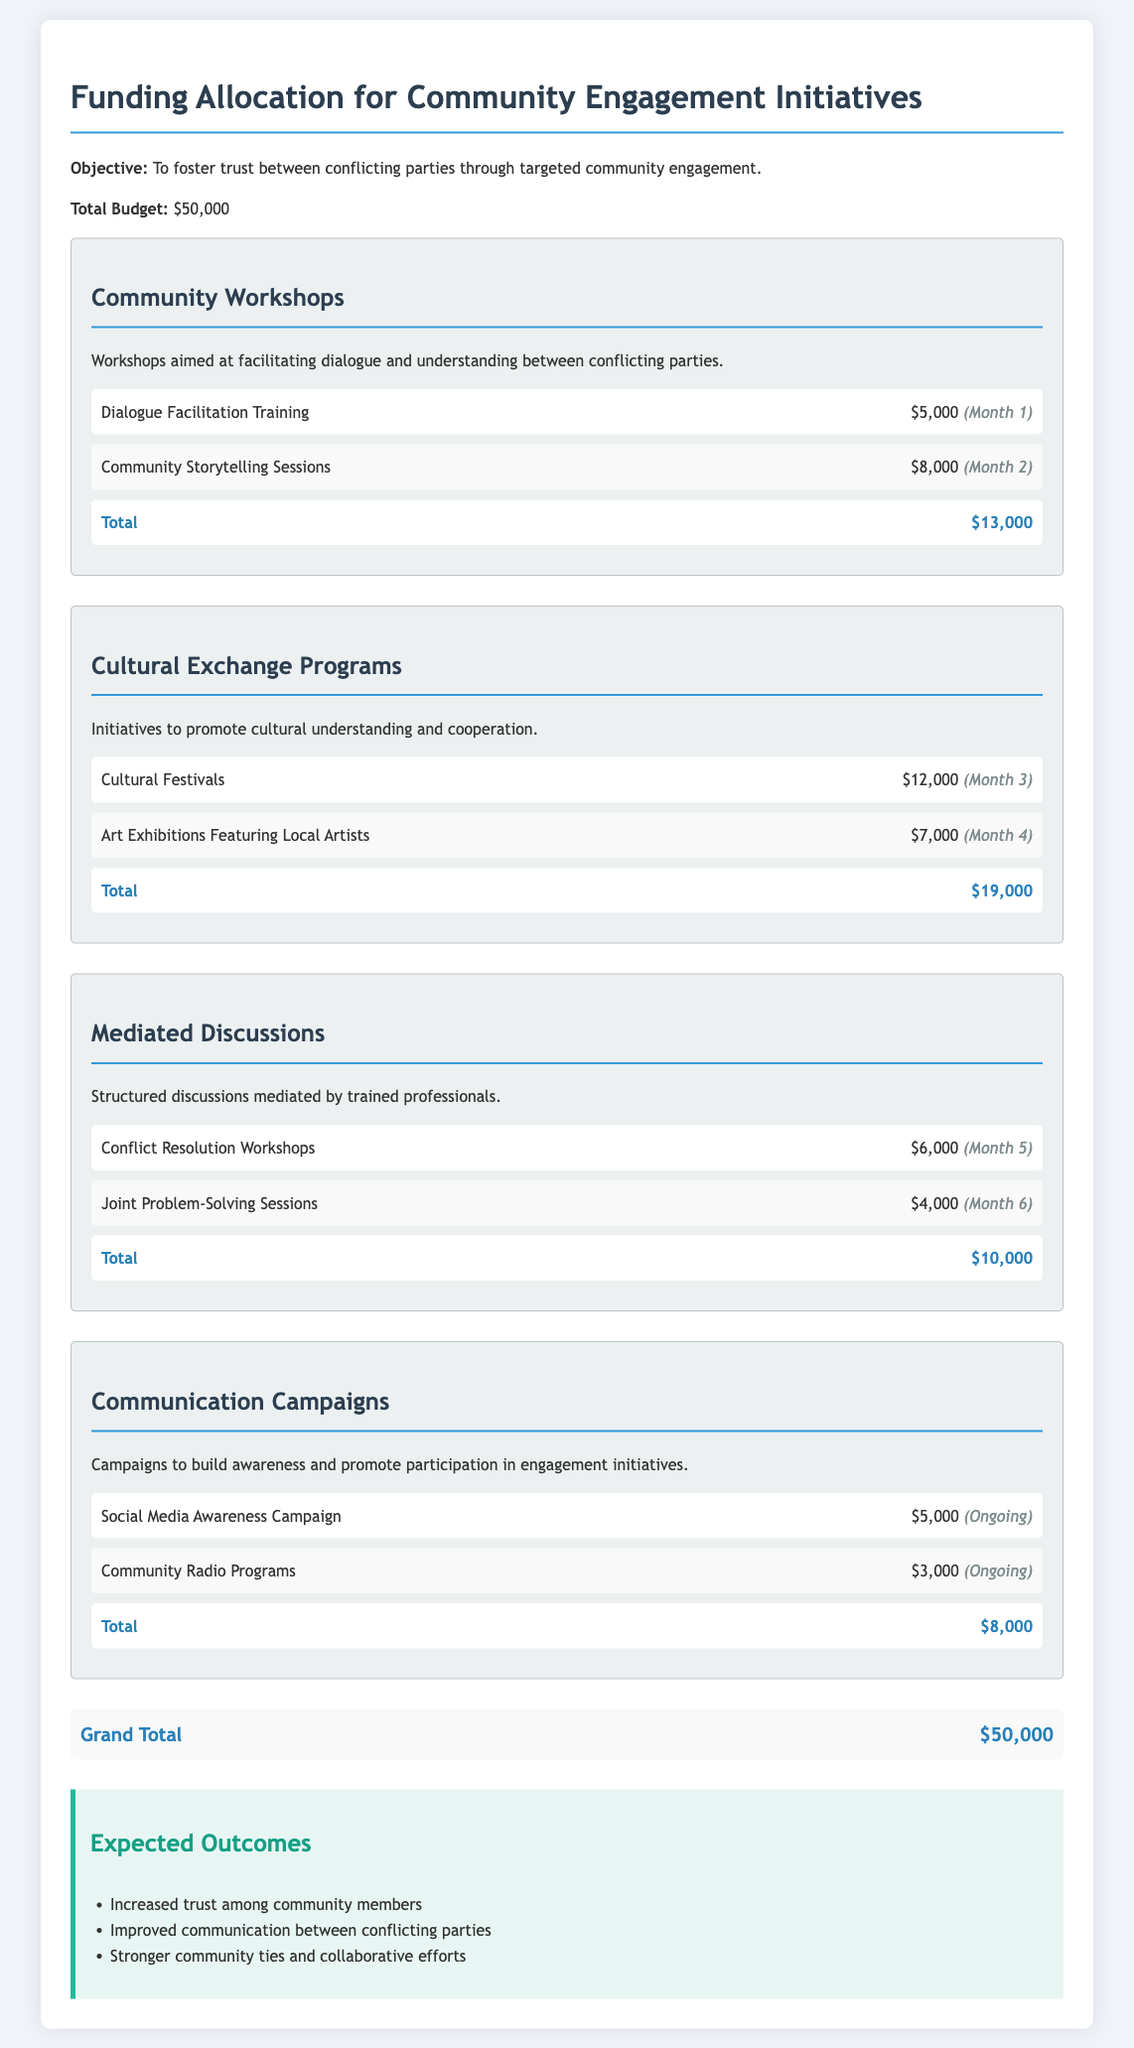what is the total budget? The total budget is stated at the beginning of the document as the overall amount allocated for the initiatives.
Answer: $50,000 how much is allocated for Cultural Festivals? The amount allocated for Cultural Festivals is listed under the Cultural Exchange Programs section.
Answer: $12,000 which activity is scheduled for Month 1? The document provides a timeline for each activity, with Month 1 having the first activity noted.
Answer: Dialogue Facilitation Training what is the total funding for Community Workshops? This is found in the budget section for Community Workshops, summarizing all activities' funding.
Answer: $13,000 how many activities are ongoing? The document specifies the timeline for activities, indicating the ongoing ones.
Answer: 2 which activity costs the least under Communication Campaigns? The prices for each activity are outlined, allowing identification of the least expensive one.
Answer: Community Radio Programs what are the expected outcomes of the initiatives? The document lists specific expected outcomes at the end of the content.
Answer: Increased trust among community members what is the total budget allocated for Mediated Discussions? The total for Mediated Discussions summarizes the individual costs in that section.
Answer: $10,000 how much is spent on workshops related to conflict resolution? This is specified within the Mediated Discussions section of the budget.
Answer: $6,000 